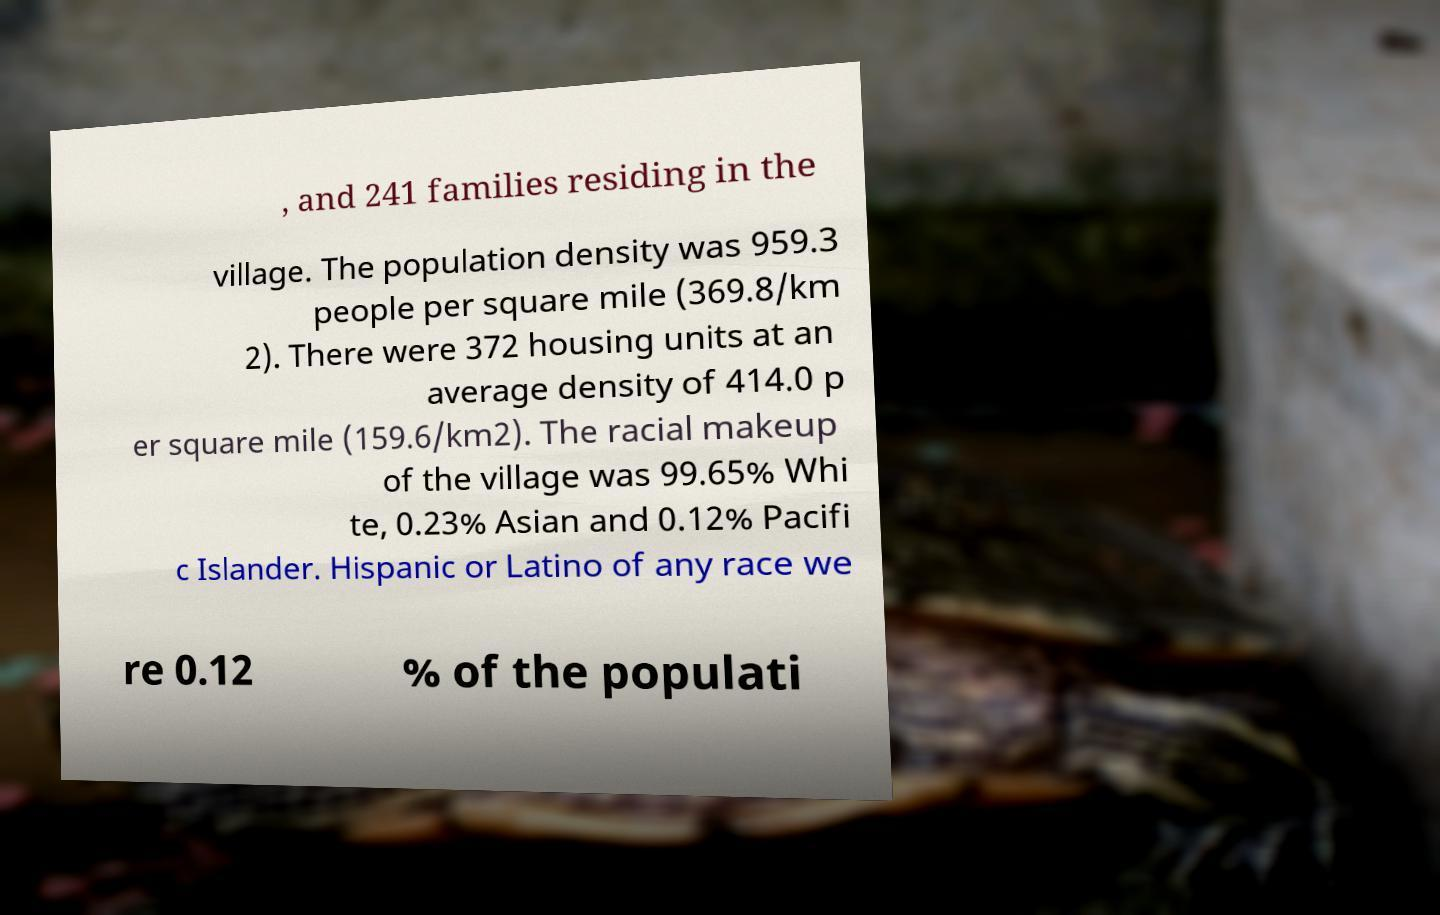Could you assist in decoding the text presented in this image and type it out clearly? , and 241 families residing in the village. The population density was 959.3 people per square mile (369.8/km 2). There were 372 housing units at an average density of 414.0 p er square mile (159.6/km2). The racial makeup of the village was 99.65% Whi te, 0.23% Asian and 0.12% Pacifi c Islander. Hispanic or Latino of any race we re 0.12 % of the populati 